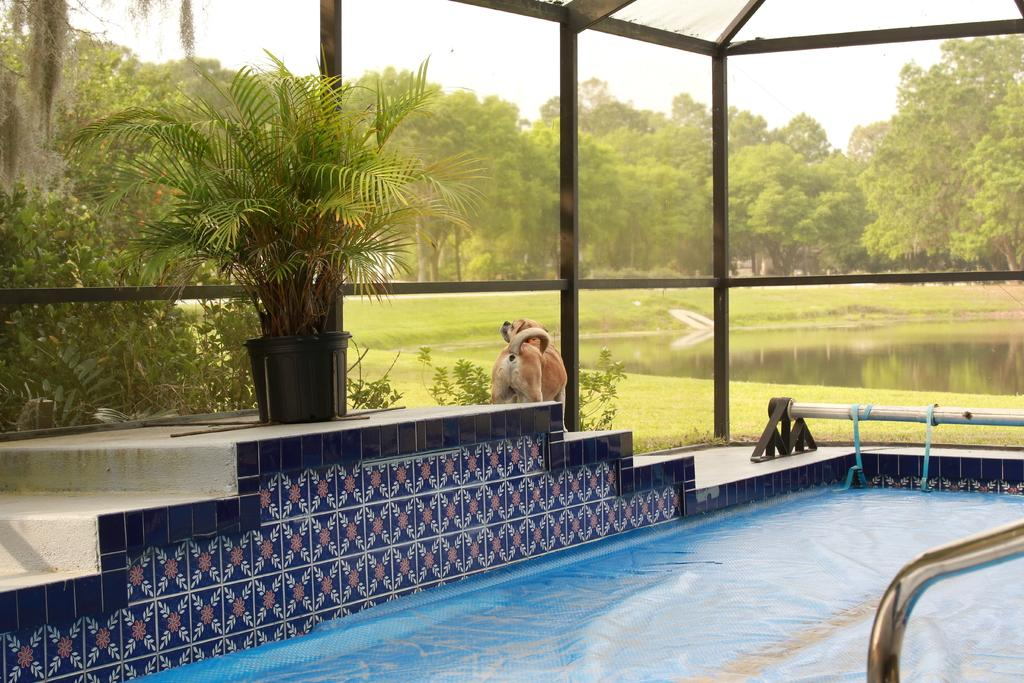What type of indoor facility is shown in the image? There is an indoor swimming pool in the image. What feature allows for visibility of the outdoor environment? The glass wall and roof are see-through, allowing for visibility of the trees and water pond. What can be seen through the glass wall and roof? Trees and a water pond are visible through the glass wall and roof. Is there any animal present in the image? Yes, there is a dog on the steps near the swimming pool. What type of music is being played in the swimming pool? There is no indication of music being played in the swimming pool in the image. What type of tank is visible in the image? There is no tank present in the image. 